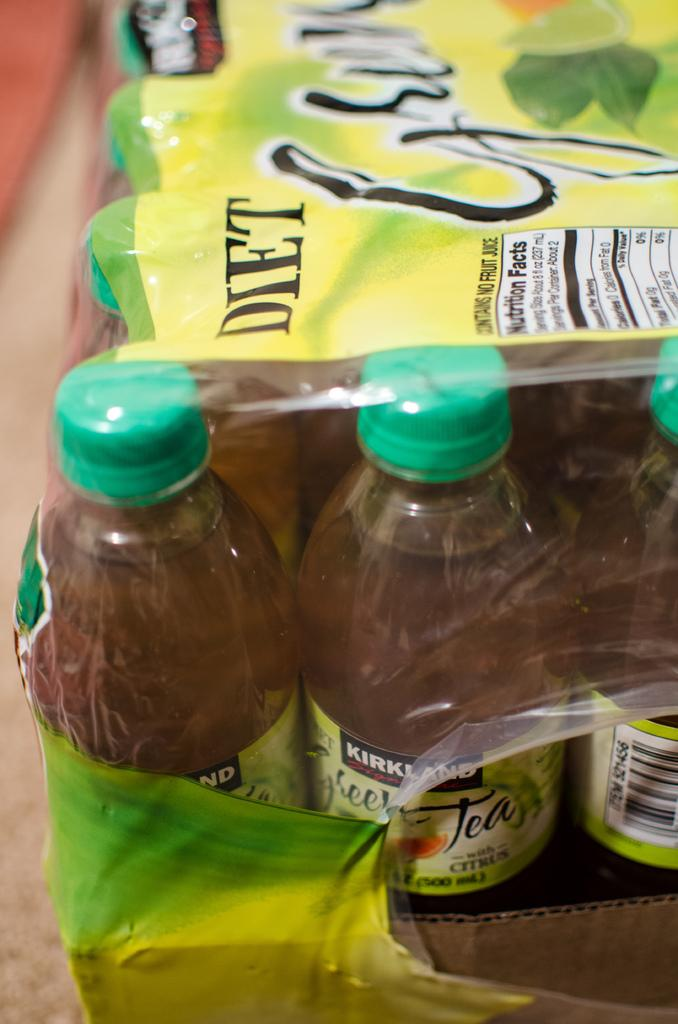<image>
Describe the image concisely. A case of diet sweet tea that is Kirkland brand. 